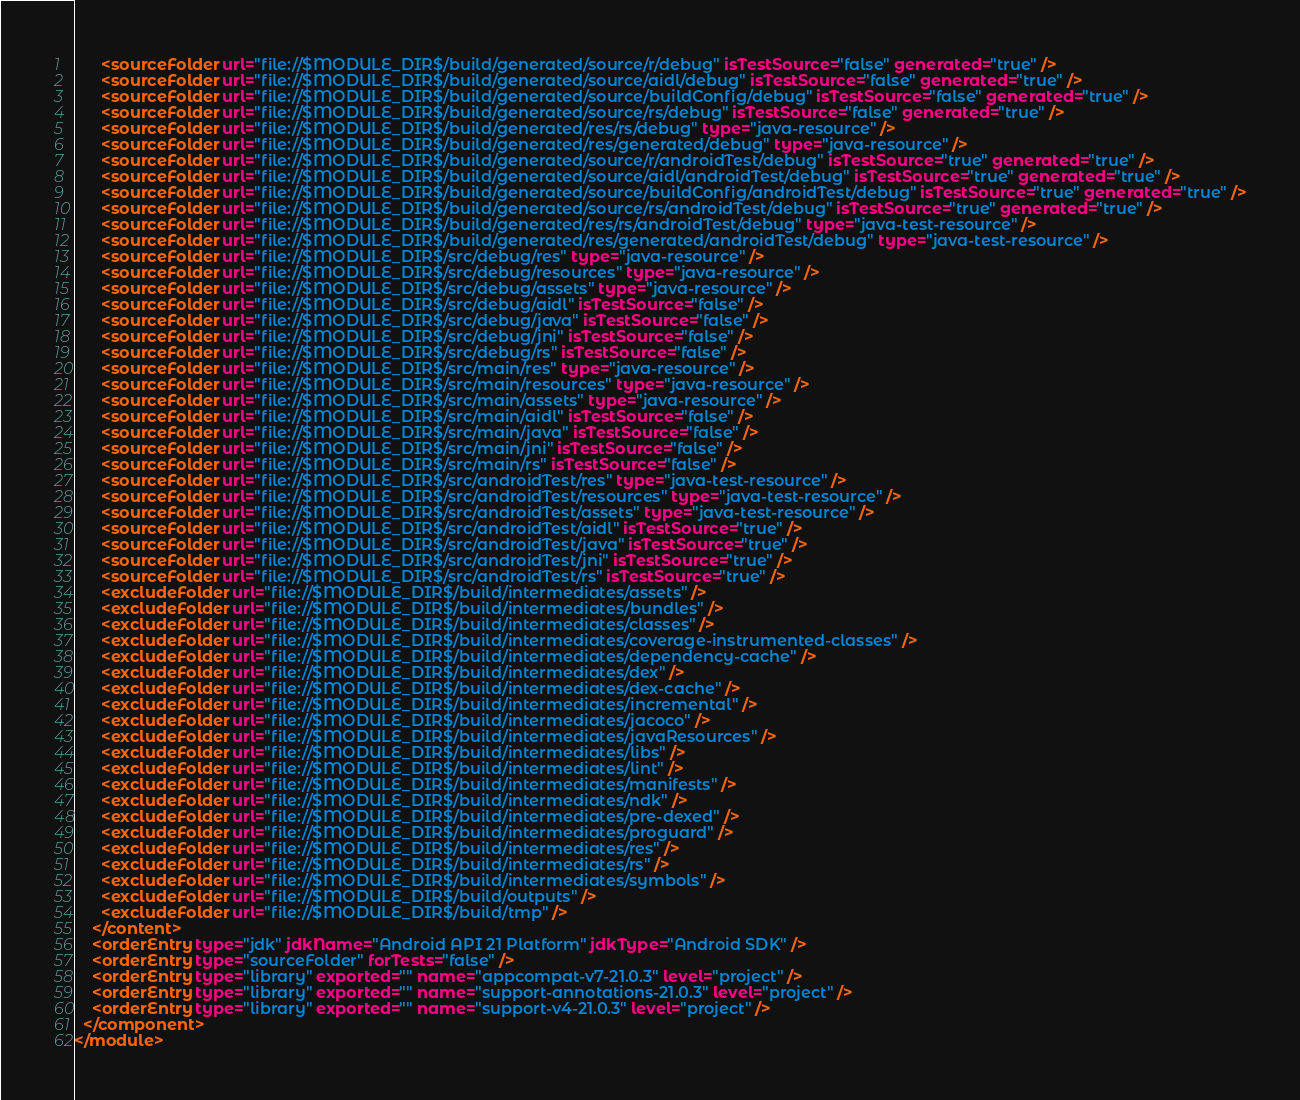<code> <loc_0><loc_0><loc_500><loc_500><_XML_>      <sourceFolder url="file://$MODULE_DIR$/build/generated/source/r/debug" isTestSource="false" generated="true" />
      <sourceFolder url="file://$MODULE_DIR$/build/generated/source/aidl/debug" isTestSource="false" generated="true" />
      <sourceFolder url="file://$MODULE_DIR$/build/generated/source/buildConfig/debug" isTestSource="false" generated="true" />
      <sourceFolder url="file://$MODULE_DIR$/build/generated/source/rs/debug" isTestSource="false" generated="true" />
      <sourceFolder url="file://$MODULE_DIR$/build/generated/res/rs/debug" type="java-resource" />
      <sourceFolder url="file://$MODULE_DIR$/build/generated/res/generated/debug" type="java-resource" />
      <sourceFolder url="file://$MODULE_DIR$/build/generated/source/r/androidTest/debug" isTestSource="true" generated="true" />
      <sourceFolder url="file://$MODULE_DIR$/build/generated/source/aidl/androidTest/debug" isTestSource="true" generated="true" />
      <sourceFolder url="file://$MODULE_DIR$/build/generated/source/buildConfig/androidTest/debug" isTestSource="true" generated="true" />
      <sourceFolder url="file://$MODULE_DIR$/build/generated/source/rs/androidTest/debug" isTestSource="true" generated="true" />
      <sourceFolder url="file://$MODULE_DIR$/build/generated/res/rs/androidTest/debug" type="java-test-resource" />
      <sourceFolder url="file://$MODULE_DIR$/build/generated/res/generated/androidTest/debug" type="java-test-resource" />
      <sourceFolder url="file://$MODULE_DIR$/src/debug/res" type="java-resource" />
      <sourceFolder url="file://$MODULE_DIR$/src/debug/resources" type="java-resource" />
      <sourceFolder url="file://$MODULE_DIR$/src/debug/assets" type="java-resource" />
      <sourceFolder url="file://$MODULE_DIR$/src/debug/aidl" isTestSource="false" />
      <sourceFolder url="file://$MODULE_DIR$/src/debug/java" isTestSource="false" />
      <sourceFolder url="file://$MODULE_DIR$/src/debug/jni" isTestSource="false" />
      <sourceFolder url="file://$MODULE_DIR$/src/debug/rs" isTestSource="false" />
      <sourceFolder url="file://$MODULE_DIR$/src/main/res" type="java-resource" />
      <sourceFolder url="file://$MODULE_DIR$/src/main/resources" type="java-resource" />
      <sourceFolder url="file://$MODULE_DIR$/src/main/assets" type="java-resource" />
      <sourceFolder url="file://$MODULE_DIR$/src/main/aidl" isTestSource="false" />
      <sourceFolder url="file://$MODULE_DIR$/src/main/java" isTestSource="false" />
      <sourceFolder url="file://$MODULE_DIR$/src/main/jni" isTestSource="false" />
      <sourceFolder url="file://$MODULE_DIR$/src/main/rs" isTestSource="false" />
      <sourceFolder url="file://$MODULE_DIR$/src/androidTest/res" type="java-test-resource" />
      <sourceFolder url="file://$MODULE_DIR$/src/androidTest/resources" type="java-test-resource" />
      <sourceFolder url="file://$MODULE_DIR$/src/androidTest/assets" type="java-test-resource" />
      <sourceFolder url="file://$MODULE_DIR$/src/androidTest/aidl" isTestSource="true" />
      <sourceFolder url="file://$MODULE_DIR$/src/androidTest/java" isTestSource="true" />
      <sourceFolder url="file://$MODULE_DIR$/src/androidTest/jni" isTestSource="true" />
      <sourceFolder url="file://$MODULE_DIR$/src/androidTest/rs" isTestSource="true" />
      <excludeFolder url="file://$MODULE_DIR$/build/intermediates/assets" />
      <excludeFolder url="file://$MODULE_DIR$/build/intermediates/bundles" />
      <excludeFolder url="file://$MODULE_DIR$/build/intermediates/classes" />
      <excludeFolder url="file://$MODULE_DIR$/build/intermediates/coverage-instrumented-classes" />
      <excludeFolder url="file://$MODULE_DIR$/build/intermediates/dependency-cache" />
      <excludeFolder url="file://$MODULE_DIR$/build/intermediates/dex" />
      <excludeFolder url="file://$MODULE_DIR$/build/intermediates/dex-cache" />
      <excludeFolder url="file://$MODULE_DIR$/build/intermediates/incremental" />
      <excludeFolder url="file://$MODULE_DIR$/build/intermediates/jacoco" />
      <excludeFolder url="file://$MODULE_DIR$/build/intermediates/javaResources" />
      <excludeFolder url="file://$MODULE_DIR$/build/intermediates/libs" />
      <excludeFolder url="file://$MODULE_DIR$/build/intermediates/lint" />
      <excludeFolder url="file://$MODULE_DIR$/build/intermediates/manifests" />
      <excludeFolder url="file://$MODULE_DIR$/build/intermediates/ndk" />
      <excludeFolder url="file://$MODULE_DIR$/build/intermediates/pre-dexed" />
      <excludeFolder url="file://$MODULE_DIR$/build/intermediates/proguard" />
      <excludeFolder url="file://$MODULE_DIR$/build/intermediates/res" />
      <excludeFolder url="file://$MODULE_DIR$/build/intermediates/rs" />
      <excludeFolder url="file://$MODULE_DIR$/build/intermediates/symbols" />
      <excludeFolder url="file://$MODULE_DIR$/build/outputs" />
      <excludeFolder url="file://$MODULE_DIR$/build/tmp" />
    </content>
    <orderEntry type="jdk" jdkName="Android API 21 Platform" jdkType="Android SDK" />
    <orderEntry type="sourceFolder" forTests="false" />
    <orderEntry type="library" exported="" name="appcompat-v7-21.0.3" level="project" />
    <orderEntry type="library" exported="" name="support-annotations-21.0.3" level="project" />
    <orderEntry type="library" exported="" name="support-v4-21.0.3" level="project" />
  </component>
</module></code> 